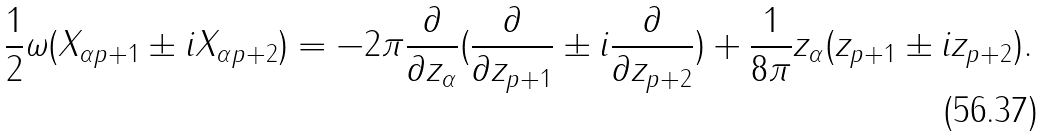<formula> <loc_0><loc_0><loc_500><loc_500>\frac { 1 } { 2 } \omega ( X _ { \alpha p + 1 } \pm i X _ { \alpha p + 2 } ) = - 2 \pi \frac { \partial } { \partial z _ { \alpha } } ( \frac { \partial } { \partial z _ { p + 1 } } \pm i \frac { \partial } { \partial z _ { p + 2 } } ) + \frac { 1 } { 8 \pi } z _ { \alpha } ( z _ { p + 1 } \pm i z _ { p + 2 } ) .</formula> 